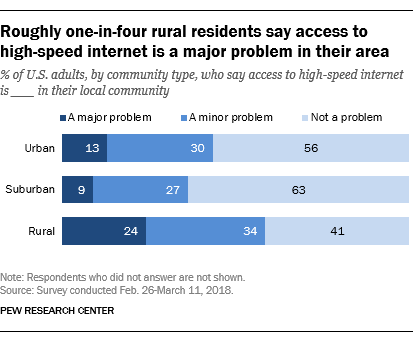Mention a couple of crucial points in this snapshot. The average number of bars in the Suburban category is less than the average number of bars in the Rural category, according to the data provided. The value of the rural darkest blue bar is 24, and it is correct. 